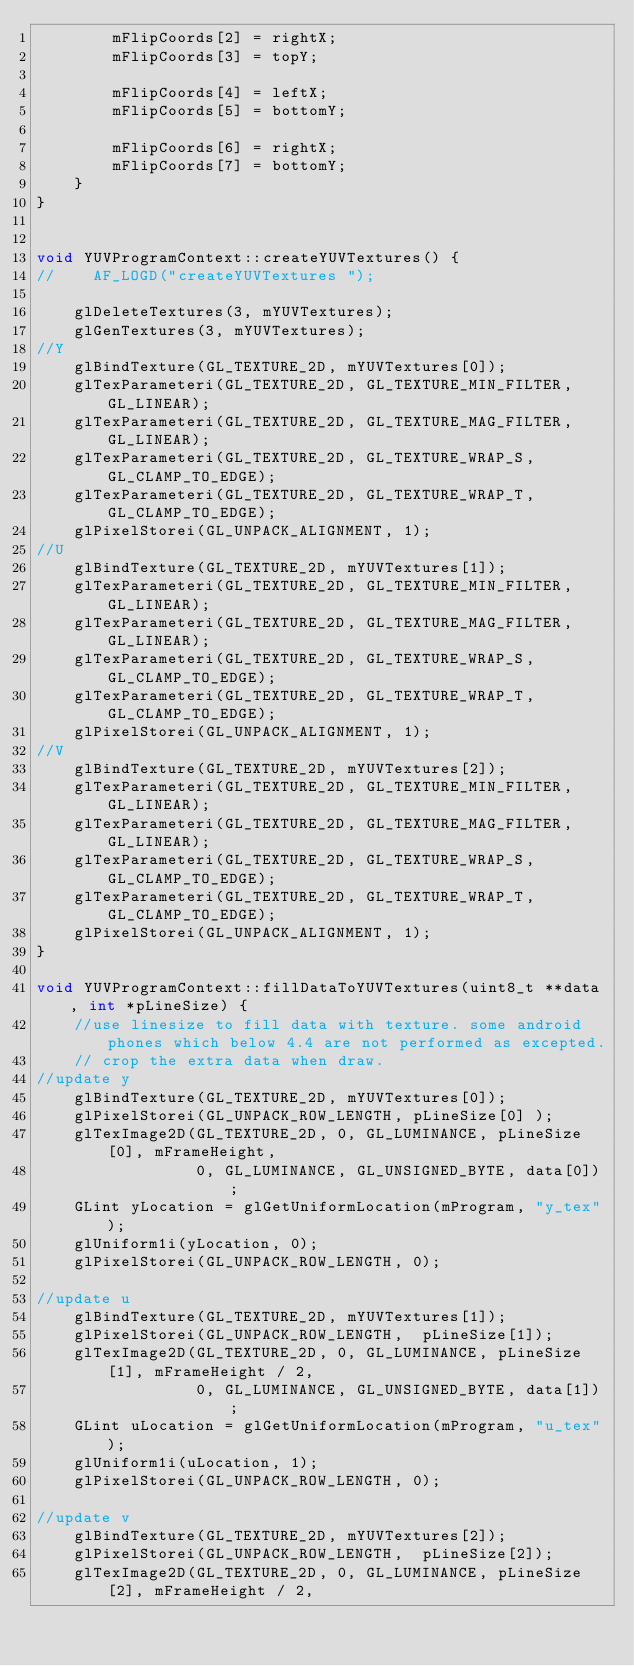Convert code to text. <code><loc_0><loc_0><loc_500><loc_500><_C++_>        mFlipCoords[2] = rightX;
        mFlipCoords[3] = topY;

        mFlipCoords[4] = leftX;
        mFlipCoords[5] = bottomY;

        mFlipCoords[6] = rightX;
        mFlipCoords[7] = bottomY;
    }
}


void YUVProgramContext::createYUVTextures() {
//    AF_LOGD("createYUVTextures ");

    glDeleteTextures(3, mYUVTextures);
    glGenTextures(3, mYUVTextures);
//Y
    glBindTexture(GL_TEXTURE_2D, mYUVTextures[0]);
    glTexParameteri(GL_TEXTURE_2D, GL_TEXTURE_MIN_FILTER, GL_LINEAR);
    glTexParameteri(GL_TEXTURE_2D, GL_TEXTURE_MAG_FILTER, GL_LINEAR);
    glTexParameteri(GL_TEXTURE_2D, GL_TEXTURE_WRAP_S, GL_CLAMP_TO_EDGE);
    glTexParameteri(GL_TEXTURE_2D, GL_TEXTURE_WRAP_T, GL_CLAMP_TO_EDGE);
    glPixelStorei(GL_UNPACK_ALIGNMENT, 1);
//U
    glBindTexture(GL_TEXTURE_2D, mYUVTextures[1]);
    glTexParameteri(GL_TEXTURE_2D, GL_TEXTURE_MIN_FILTER, GL_LINEAR);
    glTexParameteri(GL_TEXTURE_2D, GL_TEXTURE_MAG_FILTER, GL_LINEAR);
    glTexParameteri(GL_TEXTURE_2D, GL_TEXTURE_WRAP_S, GL_CLAMP_TO_EDGE);
    glTexParameteri(GL_TEXTURE_2D, GL_TEXTURE_WRAP_T, GL_CLAMP_TO_EDGE);
    glPixelStorei(GL_UNPACK_ALIGNMENT, 1);
//V
    glBindTexture(GL_TEXTURE_2D, mYUVTextures[2]);
    glTexParameteri(GL_TEXTURE_2D, GL_TEXTURE_MIN_FILTER, GL_LINEAR);
    glTexParameteri(GL_TEXTURE_2D, GL_TEXTURE_MAG_FILTER, GL_LINEAR);
    glTexParameteri(GL_TEXTURE_2D, GL_TEXTURE_WRAP_S, GL_CLAMP_TO_EDGE);
    glTexParameteri(GL_TEXTURE_2D, GL_TEXTURE_WRAP_T, GL_CLAMP_TO_EDGE);
    glPixelStorei(GL_UNPACK_ALIGNMENT, 1);
}

void YUVProgramContext::fillDataToYUVTextures(uint8_t **data, int *pLineSize) {
    //use linesize to fill data with texture. some android phones which below 4.4 are not performed as excepted.
    // crop the extra data when draw.
//update y
    glBindTexture(GL_TEXTURE_2D, mYUVTextures[0]);
    glPixelStorei(GL_UNPACK_ROW_LENGTH, pLineSize[0] );
    glTexImage2D(GL_TEXTURE_2D, 0, GL_LUMINANCE, pLineSize[0], mFrameHeight,
                 0, GL_LUMINANCE, GL_UNSIGNED_BYTE, data[0]);
    GLint yLocation = glGetUniformLocation(mProgram, "y_tex");
    glUniform1i(yLocation, 0);
    glPixelStorei(GL_UNPACK_ROW_LENGTH, 0);

//update u
    glBindTexture(GL_TEXTURE_2D, mYUVTextures[1]);
    glPixelStorei(GL_UNPACK_ROW_LENGTH,  pLineSize[1]);
    glTexImage2D(GL_TEXTURE_2D, 0, GL_LUMINANCE, pLineSize[1], mFrameHeight / 2,
                 0, GL_LUMINANCE, GL_UNSIGNED_BYTE, data[1]);
    GLint uLocation = glGetUniformLocation(mProgram, "u_tex");
    glUniform1i(uLocation, 1);
    glPixelStorei(GL_UNPACK_ROW_LENGTH, 0);

//update v
    glBindTexture(GL_TEXTURE_2D, mYUVTextures[2]);
    glPixelStorei(GL_UNPACK_ROW_LENGTH,  pLineSize[2]);
    glTexImage2D(GL_TEXTURE_2D, 0, GL_LUMINANCE, pLineSize[2], mFrameHeight / 2,</code> 